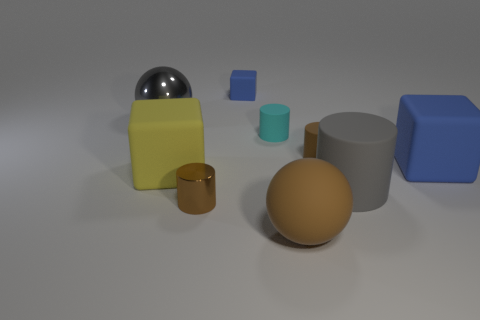Is the number of cyan objects behind the small block less than the number of metallic things on the left side of the brown metallic cylinder?
Provide a succinct answer. Yes. There is a big metallic sphere; what number of small brown things are behind it?
Your answer should be compact. 0. There is a tiny rubber object that is behind the gray shiny thing; is it the same shape as the gray thing behind the gray cylinder?
Ensure brevity in your answer.  No. How many other things are the same color as the small matte block?
Your response must be concise. 1. There is a sphere behind the big gray thing that is in front of the tiny brown cylinder on the right side of the tiny blue block; what is its material?
Your answer should be very brief. Metal. There is a ball that is in front of the big rubber block right of the big gray cylinder; what is its material?
Provide a succinct answer. Rubber. Is the number of tiny brown cylinders behind the big blue object less than the number of large yellow blocks?
Your answer should be compact. No. There is a metal thing that is right of the big yellow rubber block; what is its shape?
Give a very brief answer. Cylinder. There is a brown rubber ball; does it have the same size as the brown object behind the big blue matte block?
Offer a very short reply. No. Are there any small brown cylinders made of the same material as the large brown object?
Offer a terse response. Yes. 